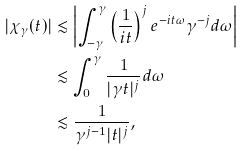<formula> <loc_0><loc_0><loc_500><loc_500>| \chi _ { \gamma } ( t ) | & \lesssim \left | \int _ { - \gamma } ^ { \gamma } \left ( \frac { 1 } { i t } \right ) ^ { j } e ^ { - i t \omega } \gamma ^ { - j } d \omega \right | \\ & \lesssim \int _ { 0 } ^ { \gamma } \frac { 1 } { | \gamma t | ^ { j } } d \omega \\ & \lesssim \frac { 1 } { \gamma ^ { j - 1 } | t | ^ { j } } ,</formula> 